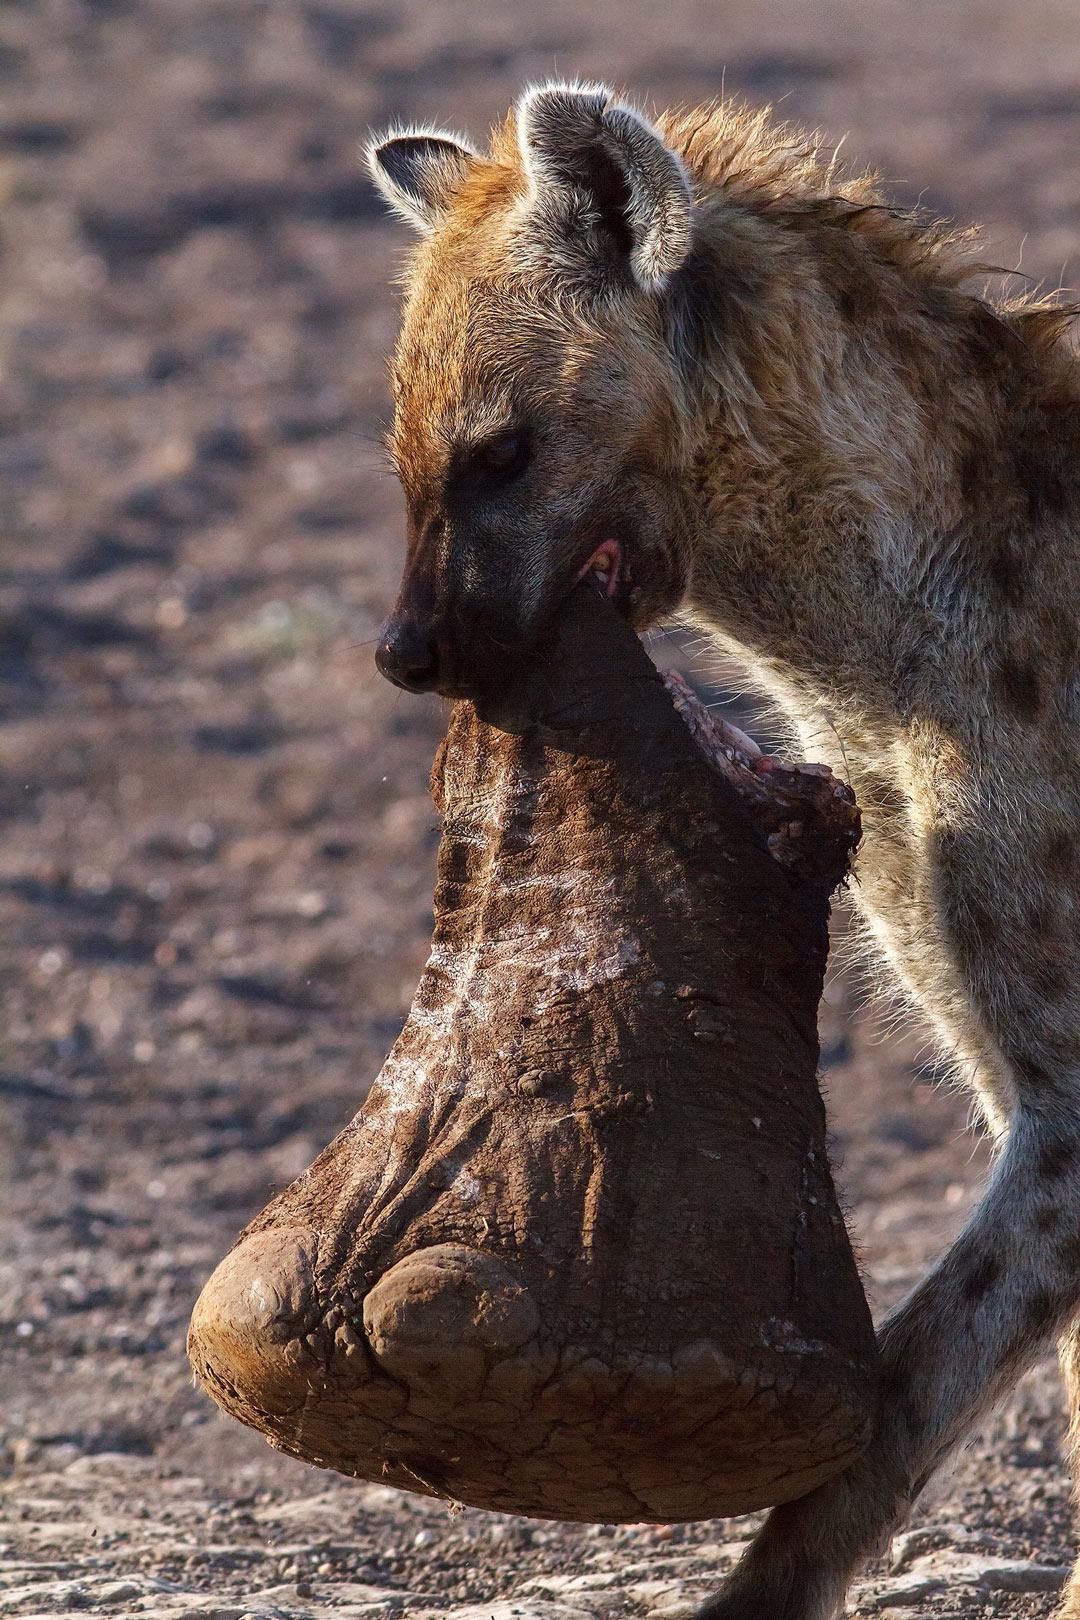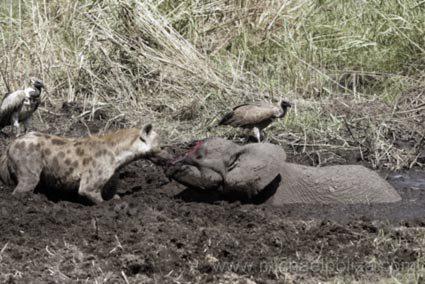The first image is the image on the left, the second image is the image on the right. Assess this claim about the two images: "Contains a picture with more than 1 Hyena.". Correct or not? Answer yes or no. No. 